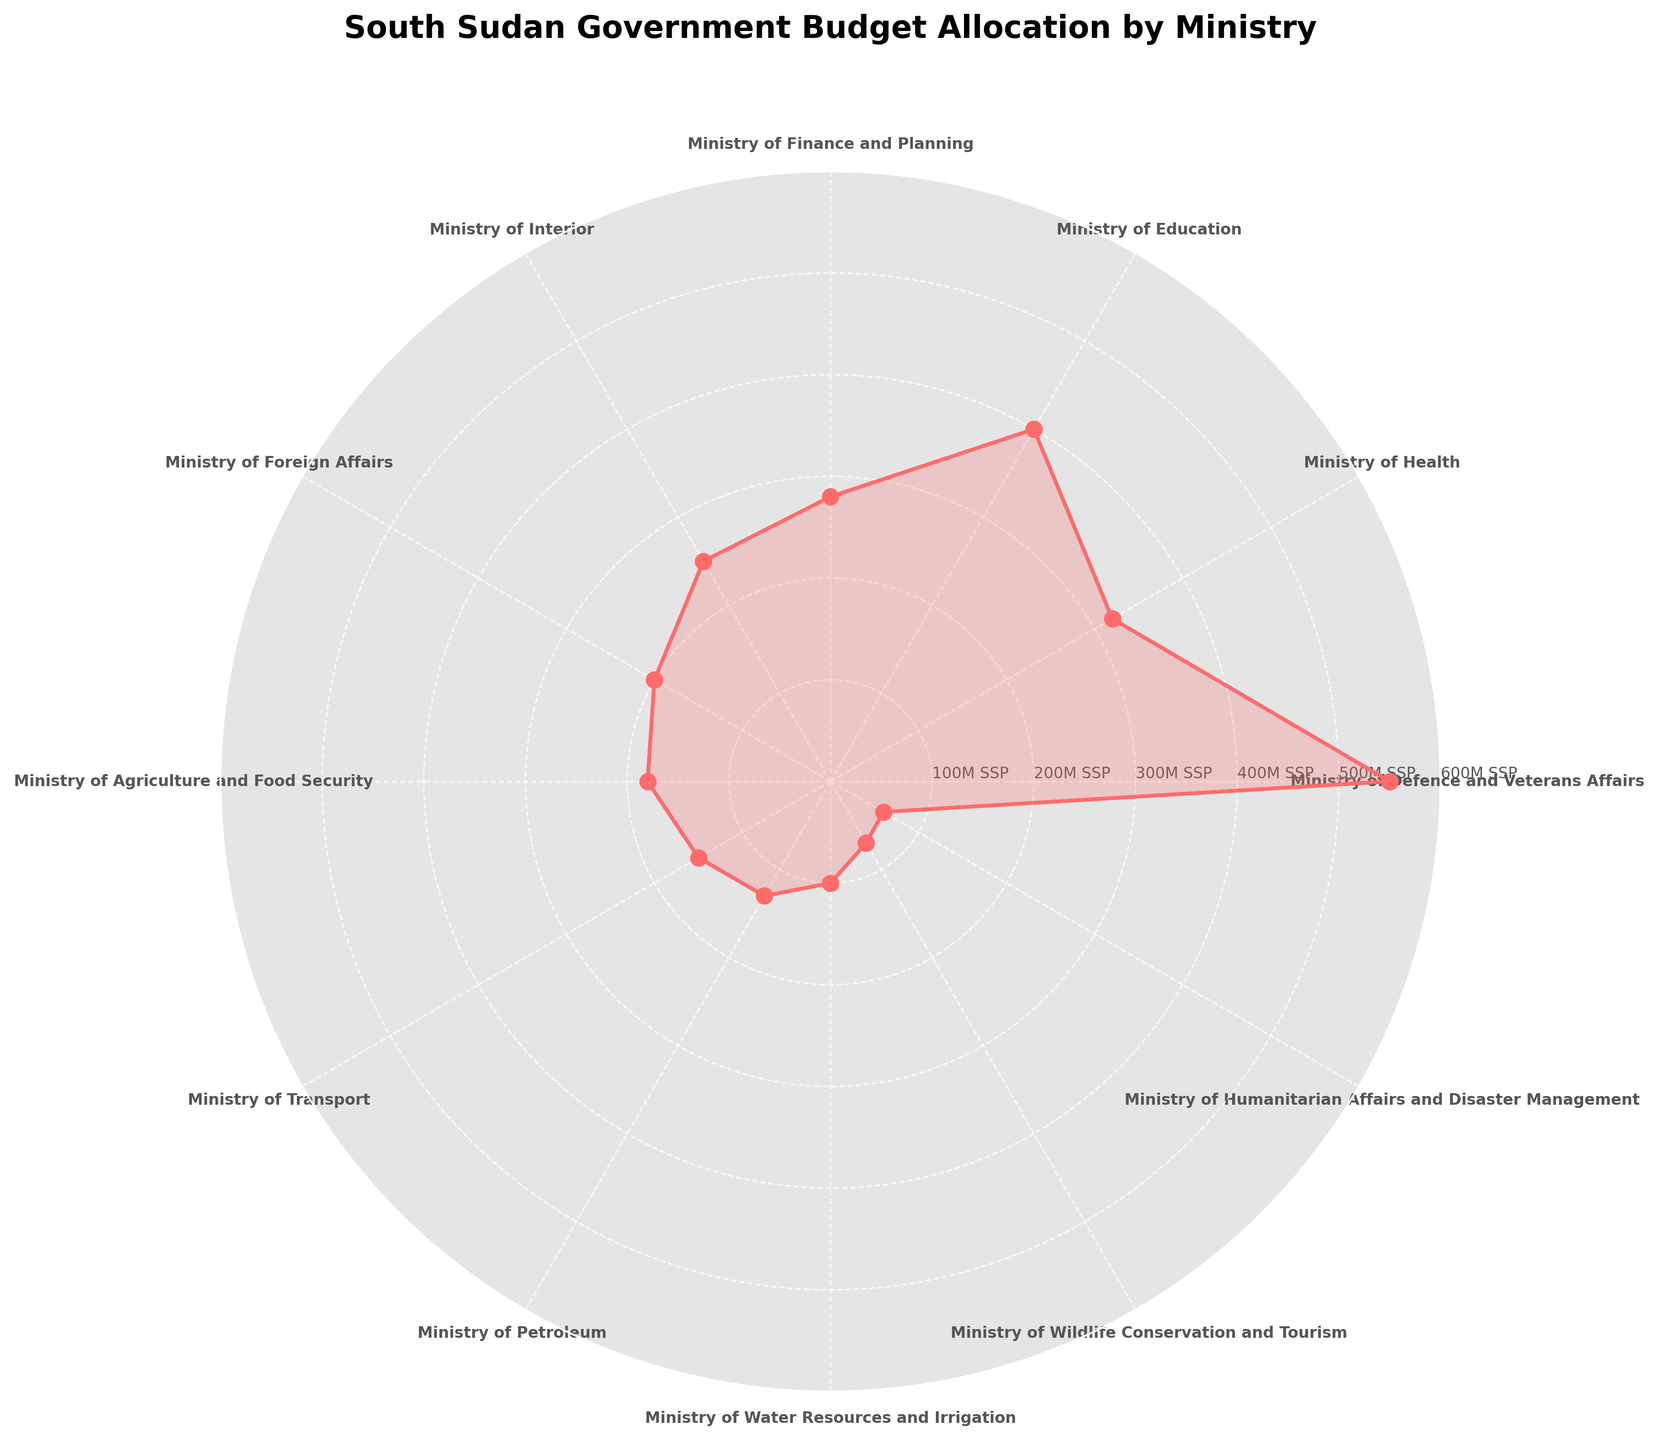Which ministry receives the highest budget allocation? The ministry with the highest peak in the rose chart represents the ministry with the largest budget allocation.
Answer: Ministry of Defence and Veterans Affairs What is the total budget allocation for the Ministry of Education and the Ministry of Health? The budget for the Ministry of Education is 400 million SSP, and for the Ministry of Health, it is 320 million SSP. Adding these together: 400 + 320 = 720 million SSP.
Answer: 720 million SSP Which ministry receives a higher budget, Ministry of Interior or Ministry of Foreign Affairs? By comparing the two points on the rose chart, the Ministry of Interior has 250 million SSP, while the Ministry of Foreign Affairs has 200 million SSP.
Answer: Ministry of Interior What are the budget allocations for the ministries with the four lowest budgets? The four smallest budgets on the chart are Ministry of Humanitarian Affairs and Disaster Management (60 million SSP), Ministry of Wildlife Conservation and Tourism (70 million SSP), Ministry of Water Resources and Irrigation (100 million SSP), and Ministry of Petroleum (130 million SSP).
Answer: 60, 70, 100, 130 million SSP What is the difference in budget allocation between the Ministry of Finance and Planning and the Ministry of Transport? The budget for the Ministry of Finance and Planning is 280 million SSP and for the Ministry of Transport, it is 150 million SSP. Subtracting these: 280 - 150 = 130 million SSP.
Answer: 130 million SSP What is the average budget allocation across all listed ministries? To find the average, sum all the budget allocations and divide by the number of ministries. Sum = 550+320+400+280+250+200+180+150+130+100+70+60 = 2690 million SSP. There are 12 ministries, so the average is 2690 / 12 = approximately 224.17 million SSP.
Answer: Approximately 224.17 million SSP Which sector receives more funding, Ministry of Agriculture and Food Security or Ministry of Water Resources and Irrigation? Comparing the two points on the rose chart, the Ministry of Agriculture and Food Security has a budget of 180 million SSP, while the Ministry of Water Resources and Irrigation has 100 million SSP.
Answer: Ministry of Agriculture and Food Security What is the budget allocation for the Ministry of Transport? Identify the corresponding point on the rose chart, the Ministry of Transport budget allocation is depicted as 150 million SSP.
Answer: 150 million SSP 